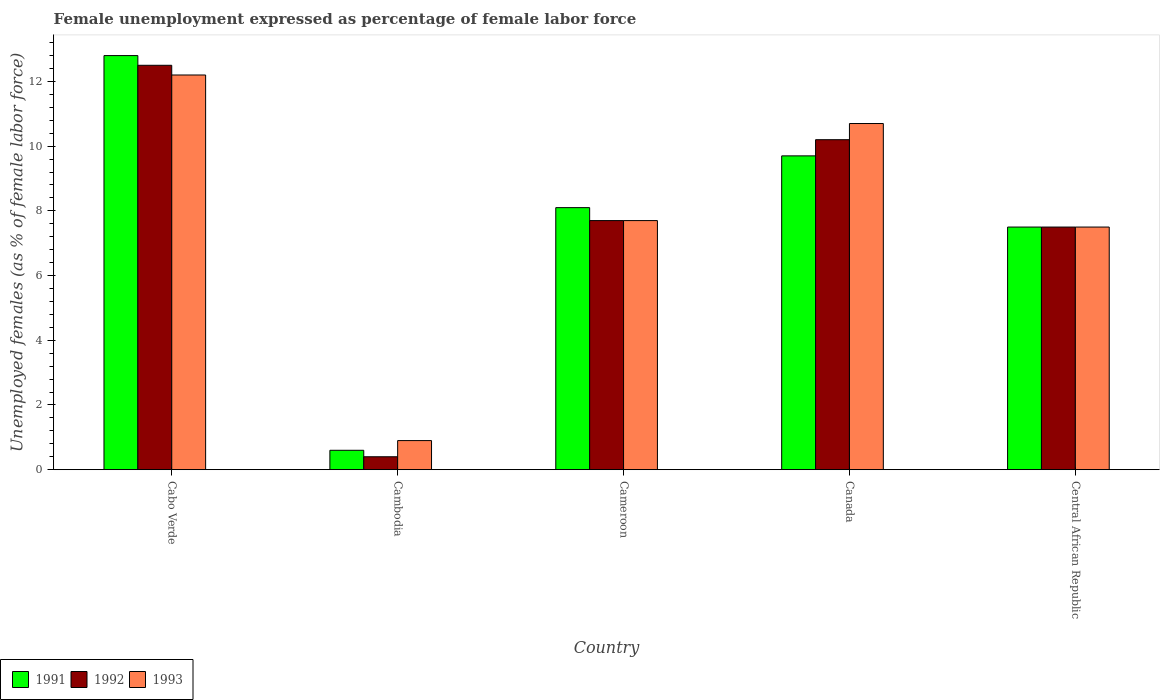How many different coloured bars are there?
Provide a succinct answer. 3. How many groups of bars are there?
Offer a terse response. 5. Are the number of bars on each tick of the X-axis equal?
Offer a very short reply. Yes. How many bars are there on the 1st tick from the left?
Your response must be concise. 3. How many bars are there on the 4th tick from the right?
Provide a short and direct response. 3. What is the label of the 5th group of bars from the left?
Provide a succinct answer. Central African Republic. In how many cases, is the number of bars for a given country not equal to the number of legend labels?
Provide a short and direct response. 0. Across all countries, what is the maximum unemployment in females in in 1993?
Provide a succinct answer. 12.2. Across all countries, what is the minimum unemployment in females in in 1993?
Your response must be concise. 0.9. In which country was the unemployment in females in in 1993 maximum?
Your answer should be compact. Cabo Verde. In which country was the unemployment in females in in 1993 minimum?
Your answer should be very brief. Cambodia. What is the total unemployment in females in in 1993 in the graph?
Offer a terse response. 39. What is the difference between the unemployment in females in in 1991 in Cambodia and that in Cameroon?
Make the answer very short. -7.5. What is the difference between the unemployment in females in in 1992 in Cameroon and the unemployment in females in in 1993 in Cabo Verde?
Provide a short and direct response. -4.5. What is the average unemployment in females in in 1992 per country?
Provide a succinct answer. 7.66. What is the difference between the unemployment in females in of/in 1992 and unemployment in females in of/in 1991 in Canada?
Give a very brief answer. 0.5. What is the ratio of the unemployment in females in in 1992 in Cameroon to that in Central African Republic?
Provide a succinct answer. 1.03. What is the difference between the highest and the lowest unemployment in females in in 1991?
Provide a succinct answer. 12.2. In how many countries, is the unemployment in females in in 1992 greater than the average unemployment in females in in 1992 taken over all countries?
Offer a terse response. 3. What does the 1st bar from the right in Cabo Verde represents?
Provide a succinct answer. 1993. Are all the bars in the graph horizontal?
Ensure brevity in your answer.  No. What is the difference between two consecutive major ticks on the Y-axis?
Offer a terse response. 2. Are the values on the major ticks of Y-axis written in scientific E-notation?
Provide a succinct answer. No. Where does the legend appear in the graph?
Ensure brevity in your answer.  Bottom left. How are the legend labels stacked?
Your response must be concise. Horizontal. What is the title of the graph?
Make the answer very short. Female unemployment expressed as percentage of female labor force. Does "1979" appear as one of the legend labels in the graph?
Your answer should be very brief. No. What is the label or title of the X-axis?
Provide a short and direct response. Country. What is the label or title of the Y-axis?
Offer a terse response. Unemployed females (as % of female labor force). What is the Unemployed females (as % of female labor force) in 1991 in Cabo Verde?
Ensure brevity in your answer.  12.8. What is the Unemployed females (as % of female labor force) of 1992 in Cabo Verde?
Give a very brief answer. 12.5. What is the Unemployed females (as % of female labor force) of 1993 in Cabo Verde?
Give a very brief answer. 12.2. What is the Unemployed females (as % of female labor force) of 1991 in Cambodia?
Your answer should be compact. 0.6. What is the Unemployed females (as % of female labor force) of 1992 in Cambodia?
Your answer should be very brief. 0.4. What is the Unemployed females (as % of female labor force) of 1993 in Cambodia?
Your answer should be very brief. 0.9. What is the Unemployed females (as % of female labor force) of 1991 in Cameroon?
Your response must be concise. 8.1. What is the Unemployed females (as % of female labor force) in 1992 in Cameroon?
Provide a succinct answer. 7.7. What is the Unemployed females (as % of female labor force) of 1993 in Cameroon?
Offer a very short reply. 7.7. What is the Unemployed females (as % of female labor force) in 1991 in Canada?
Give a very brief answer. 9.7. What is the Unemployed females (as % of female labor force) in 1992 in Canada?
Make the answer very short. 10.2. What is the Unemployed females (as % of female labor force) in 1993 in Canada?
Ensure brevity in your answer.  10.7. What is the Unemployed females (as % of female labor force) of 1992 in Central African Republic?
Give a very brief answer. 7.5. Across all countries, what is the maximum Unemployed females (as % of female labor force) of 1991?
Your answer should be very brief. 12.8. Across all countries, what is the maximum Unemployed females (as % of female labor force) in 1992?
Provide a succinct answer. 12.5. Across all countries, what is the maximum Unemployed females (as % of female labor force) of 1993?
Ensure brevity in your answer.  12.2. Across all countries, what is the minimum Unemployed females (as % of female labor force) of 1991?
Give a very brief answer. 0.6. Across all countries, what is the minimum Unemployed females (as % of female labor force) in 1992?
Offer a very short reply. 0.4. Across all countries, what is the minimum Unemployed females (as % of female labor force) in 1993?
Provide a succinct answer. 0.9. What is the total Unemployed females (as % of female labor force) of 1991 in the graph?
Offer a very short reply. 38.7. What is the total Unemployed females (as % of female labor force) of 1992 in the graph?
Ensure brevity in your answer.  38.3. What is the difference between the Unemployed females (as % of female labor force) of 1991 in Cabo Verde and that in Cambodia?
Your answer should be very brief. 12.2. What is the difference between the Unemployed females (as % of female labor force) in 1992 in Cabo Verde and that in Cambodia?
Make the answer very short. 12.1. What is the difference between the Unemployed females (as % of female labor force) of 1992 in Cabo Verde and that in Cameroon?
Keep it short and to the point. 4.8. What is the difference between the Unemployed females (as % of female labor force) of 1993 in Cabo Verde and that in Cameroon?
Give a very brief answer. 4.5. What is the difference between the Unemployed females (as % of female labor force) in 1991 in Cabo Verde and that in Canada?
Your answer should be very brief. 3.1. What is the difference between the Unemployed females (as % of female labor force) in 1993 in Cabo Verde and that in Canada?
Provide a succinct answer. 1.5. What is the difference between the Unemployed females (as % of female labor force) in 1991 in Cabo Verde and that in Central African Republic?
Make the answer very short. 5.3. What is the difference between the Unemployed females (as % of female labor force) of 1993 in Cabo Verde and that in Central African Republic?
Make the answer very short. 4.7. What is the difference between the Unemployed females (as % of female labor force) in 1991 in Cambodia and that in Cameroon?
Provide a succinct answer. -7.5. What is the difference between the Unemployed females (as % of female labor force) of 1993 in Cambodia and that in Cameroon?
Offer a very short reply. -6.8. What is the difference between the Unemployed females (as % of female labor force) of 1991 in Cambodia and that in Canada?
Provide a short and direct response. -9.1. What is the difference between the Unemployed females (as % of female labor force) in 1992 in Cambodia and that in Canada?
Your answer should be compact. -9.8. What is the difference between the Unemployed females (as % of female labor force) in 1993 in Cambodia and that in Canada?
Provide a short and direct response. -9.8. What is the difference between the Unemployed females (as % of female labor force) in 1991 in Cambodia and that in Central African Republic?
Give a very brief answer. -6.9. What is the difference between the Unemployed females (as % of female labor force) in 1992 in Cambodia and that in Central African Republic?
Provide a succinct answer. -7.1. What is the difference between the Unemployed females (as % of female labor force) of 1993 in Cambodia and that in Central African Republic?
Make the answer very short. -6.6. What is the difference between the Unemployed females (as % of female labor force) of 1992 in Cameroon and that in Canada?
Ensure brevity in your answer.  -2.5. What is the difference between the Unemployed females (as % of female labor force) in 1991 in Canada and that in Central African Republic?
Provide a succinct answer. 2.2. What is the difference between the Unemployed females (as % of female labor force) in 1992 in Canada and that in Central African Republic?
Offer a very short reply. 2.7. What is the difference between the Unemployed females (as % of female labor force) of 1993 in Canada and that in Central African Republic?
Offer a very short reply. 3.2. What is the difference between the Unemployed females (as % of female labor force) in 1992 in Cabo Verde and the Unemployed females (as % of female labor force) in 1993 in Cambodia?
Offer a very short reply. 11.6. What is the difference between the Unemployed females (as % of female labor force) in 1991 in Cabo Verde and the Unemployed females (as % of female labor force) in 1993 in Cameroon?
Your answer should be compact. 5.1. What is the difference between the Unemployed females (as % of female labor force) of 1991 in Cabo Verde and the Unemployed females (as % of female labor force) of 1992 in Canada?
Ensure brevity in your answer.  2.6. What is the difference between the Unemployed females (as % of female labor force) in 1991 in Cabo Verde and the Unemployed females (as % of female labor force) in 1993 in Canada?
Ensure brevity in your answer.  2.1. What is the difference between the Unemployed females (as % of female labor force) of 1992 in Cabo Verde and the Unemployed females (as % of female labor force) of 1993 in Canada?
Make the answer very short. 1.8. What is the difference between the Unemployed females (as % of female labor force) in 1991 in Cambodia and the Unemployed females (as % of female labor force) in 1992 in Cameroon?
Provide a succinct answer. -7.1. What is the difference between the Unemployed females (as % of female labor force) of 1991 in Cambodia and the Unemployed females (as % of female labor force) of 1992 in Canada?
Your answer should be very brief. -9.6. What is the difference between the Unemployed females (as % of female labor force) in 1992 in Cambodia and the Unemployed females (as % of female labor force) in 1993 in Canada?
Make the answer very short. -10.3. What is the difference between the Unemployed females (as % of female labor force) in 1991 in Cambodia and the Unemployed females (as % of female labor force) in 1992 in Central African Republic?
Ensure brevity in your answer.  -6.9. What is the difference between the Unemployed females (as % of female labor force) of 1991 in Cambodia and the Unemployed females (as % of female labor force) of 1993 in Central African Republic?
Ensure brevity in your answer.  -6.9. What is the difference between the Unemployed females (as % of female labor force) of 1992 in Cameroon and the Unemployed females (as % of female labor force) of 1993 in Canada?
Make the answer very short. -3. What is the difference between the Unemployed females (as % of female labor force) in 1991 in Cameroon and the Unemployed females (as % of female labor force) in 1992 in Central African Republic?
Offer a terse response. 0.6. What is the difference between the Unemployed females (as % of female labor force) in 1991 in Cameroon and the Unemployed females (as % of female labor force) in 1993 in Central African Republic?
Offer a very short reply. 0.6. What is the difference between the Unemployed females (as % of female labor force) in 1992 in Cameroon and the Unemployed females (as % of female labor force) in 1993 in Central African Republic?
Your response must be concise. 0.2. What is the difference between the Unemployed females (as % of female labor force) in 1991 in Canada and the Unemployed females (as % of female labor force) in 1993 in Central African Republic?
Your answer should be compact. 2.2. What is the average Unemployed females (as % of female labor force) in 1991 per country?
Your answer should be compact. 7.74. What is the average Unemployed females (as % of female labor force) in 1992 per country?
Provide a succinct answer. 7.66. What is the average Unemployed females (as % of female labor force) of 1993 per country?
Make the answer very short. 7.8. What is the difference between the Unemployed females (as % of female labor force) of 1991 and Unemployed females (as % of female labor force) of 1992 in Cabo Verde?
Keep it short and to the point. 0.3. What is the difference between the Unemployed females (as % of female labor force) in 1992 and Unemployed females (as % of female labor force) in 1993 in Cabo Verde?
Your response must be concise. 0.3. What is the difference between the Unemployed females (as % of female labor force) of 1991 and Unemployed females (as % of female labor force) of 1993 in Cambodia?
Your response must be concise. -0.3. What is the difference between the Unemployed females (as % of female labor force) in 1992 and Unemployed females (as % of female labor force) in 1993 in Cambodia?
Make the answer very short. -0.5. What is the difference between the Unemployed females (as % of female labor force) of 1992 and Unemployed females (as % of female labor force) of 1993 in Cameroon?
Make the answer very short. 0. What is the difference between the Unemployed females (as % of female labor force) of 1991 and Unemployed females (as % of female labor force) of 1992 in Canada?
Your answer should be compact. -0.5. What is the difference between the Unemployed females (as % of female labor force) of 1991 and Unemployed females (as % of female labor force) of 1993 in Canada?
Your response must be concise. -1. What is the difference between the Unemployed females (as % of female labor force) of 1992 and Unemployed females (as % of female labor force) of 1993 in Canada?
Your answer should be compact. -0.5. What is the difference between the Unemployed females (as % of female labor force) in 1991 and Unemployed females (as % of female labor force) in 1992 in Central African Republic?
Provide a short and direct response. 0. What is the difference between the Unemployed females (as % of female labor force) of 1991 and Unemployed females (as % of female labor force) of 1993 in Central African Republic?
Offer a terse response. 0. What is the difference between the Unemployed females (as % of female labor force) in 1992 and Unemployed females (as % of female labor force) in 1993 in Central African Republic?
Provide a succinct answer. 0. What is the ratio of the Unemployed females (as % of female labor force) in 1991 in Cabo Verde to that in Cambodia?
Make the answer very short. 21.33. What is the ratio of the Unemployed females (as % of female labor force) in 1992 in Cabo Verde to that in Cambodia?
Your answer should be compact. 31.25. What is the ratio of the Unemployed females (as % of female labor force) in 1993 in Cabo Verde to that in Cambodia?
Ensure brevity in your answer.  13.56. What is the ratio of the Unemployed females (as % of female labor force) of 1991 in Cabo Verde to that in Cameroon?
Provide a short and direct response. 1.58. What is the ratio of the Unemployed females (as % of female labor force) in 1992 in Cabo Verde to that in Cameroon?
Provide a short and direct response. 1.62. What is the ratio of the Unemployed females (as % of female labor force) of 1993 in Cabo Verde to that in Cameroon?
Your answer should be very brief. 1.58. What is the ratio of the Unemployed females (as % of female labor force) in 1991 in Cabo Verde to that in Canada?
Offer a very short reply. 1.32. What is the ratio of the Unemployed females (as % of female labor force) in 1992 in Cabo Verde to that in Canada?
Provide a short and direct response. 1.23. What is the ratio of the Unemployed females (as % of female labor force) in 1993 in Cabo Verde to that in Canada?
Offer a terse response. 1.14. What is the ratio of the Unemployed females (as % of female labor force) in 1991 in Cabo Verde to that in Central African Republic?
Ensure brevity in your answer.  1.71. What is the ratio of the Unemployed females (as % of female labor force) of 1992 in Cabo Verde to that in Central African Republic?
Provide a succinct answer. 1.67. What is the ratio of the Unemployed females (as % of female labor force) of 1993 in Cabo Verde to that in Central African Republic?
Your response must be concise. 1.63. What is the ratio of the Unemployed females (as % of female labor force) in 1991 in Cambodia to that in Cameroon?
Provide a short and direct response. 0.07. What is the ratio of the Unemployed females (as % of female labor force) in 1992 in Cambodia to that in Cameroon?
Give a very brief answer. 0.05. What is the ratio of the Unemployed females (as % of female labor force) of 1993 in Cambodia to that in Cameroon?
Your answer should be compact. 0.12. What is the ratio of the Unemployed females (as % of female labor force) in 1991 in Cambodia to that in Canada?
Offer a terse response. 0.06. What is the ratio of the Unemployed females (as % of female labor force) of 1992 in Cambodia to that in Canada?
Keep it short and to the point. 0.04. What is the ratio of the Unemployed females (as % of female labor force) of 1993 in Cambodia to that in Canada?
Your answer should be compact. 0.08. What is the ratio of the Unemployed females (as % of female labor force) in 1991 in Cambodia to that in Central African Republic?
Your answer should be compact. 0.08. What is the ratio of the Unemployed females (as % of female labor force) of 1992 in Cambodia to that in Central African Republic?
Ensure brevity in your answer.  0.05. What is the ratio of the Unemployed females (as % of female labor force) of 1993 in Cambodia to that in Central African Republic?
Offer a very short reply. 0.12. What is the ratio of the Unemployed females (as % of female labor force) in 1991 in Cameroon to that in Canada?
Your response must be concise. 0.84. What is the ratio of the Unemployed females (as % of female labor force) of 1992 in Cameroon to that in Canada?
Give a very brief answer. 0.75. What is the ratio of the Unemployed females (as % of female labor force) of 1993 in Cameroon to that in Canada?
Give a very brief answer. 0.72. What is the ratio of the Unemployed females (as % of female labor force) of 1992 in Cameroon to that in Central African Republic?
Offer a terse response. 1.03. What is the ratio of the Unemployed females (as % of female labor force) of 1993 in Cameroon to that in Central African Republic?
Make the answer very short. 1.03. What is the ratio of the Unemployed females (as % of female labor force) in 1991 in Canada to that in Central African Republic?
Offer a terse response. 1.29. What is the ratio of the Unemployed females (as % of female labor force) in 1992 in Canada to that in Central African Republic?
Your answer should be very brief. 1.36. What is the ratio of the Unemployed females (as % of female labor force) in 1993 in Canada to that in Central African Republic?
Your answer should be very brief. 1.43. What is the difference between the highest and the second highest Unemployed females (as % of female labor force) of 1992?
Keep it short and to the point. 2.3. What is the difference between the highest and the second highest Unemployed females (as % of female labor force) in 1993?
Provide a short and direct response. 1.5. What is the difference between the highest and the lowest Unemployed females (as % of female labor force) of 1992?
Offer a terse response. 12.1. What is the difference between the highest and the lowest Unemployed females (as % of female labor force) in 1993?
Keep it short and to the point. 11.3. 